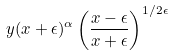Convert formula to latex. <formula><loc_0><loc_0><loc_500><loc_500>y ( x + \epsilon ) ^ { \alpha } \left ( \frac { x - \epsilon } { x + \epsilon } \right ) ^ { 1 / 2 \epsilon }</formula> 